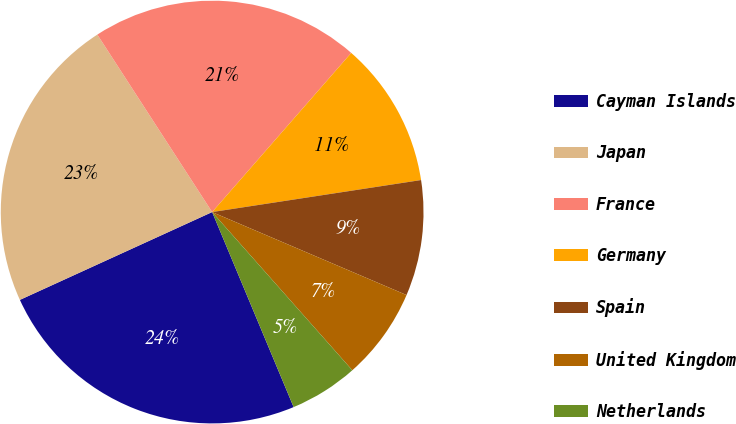Convert chart to OTSL. <chart><loc_0><loc_0><loc_500><loc_500><pie_chart><fcel>Cayman Islands<fcel>Japan<fcel>France<fcel>Germany<fcel>Spain<fcel>United Kingdom<fcel>Netherlands<nl><fcel>24.48%<fcel>22.68%<fcel>20.57%<fcel>11.15%<fcel>8.84%<fcel>7.04%<fcel>5.24%<nl></chart> 